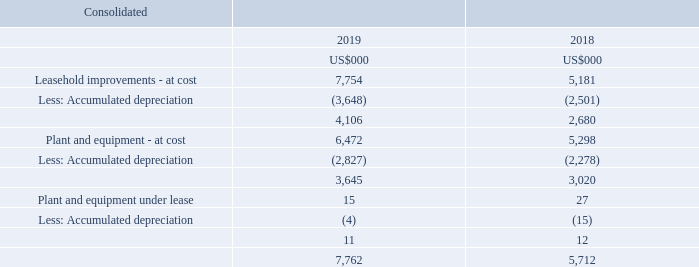Note 9. Non-current assets - property, plant and equipment
Property, plant and equipment secured under finance leases
Refer to note 24 for further information on property, plant and equipment secured under finance leases.
Accounting policy for property, plant and equipment
Plant and equipment are stated at cost less accumulated depreciation and any accumulated impairment losses. Cost includes expenditure that is directly attributable to the acquisition of the items. Subsequent costs are included in the assets carrying amount or recognised as a separate asset, as appropriate, only when it is probable that future economic benefits associated with the item will flow to the group and the cost of the item can be measured reliably.
Plant and equipment are depreciated and leasehold improvements are amortised over their estimated useful lives using the straightline method. Assets held under finance lease are depreciated over their expected useful lives as owned assets or, where shorter, the term of the relevant lease.
What is the total consolidated amount in 2019?
Answer scale should be: thousand. 7,762. When are subsequent costs included? When it is probable that future economic benefits associated with the item will flow to the group and the cost of the item can be measured reliably. What are the years included in the table? 2019, 2018. Which year had a higher total consolidated Non-current assets value?  7,762 > 5,712 
Answer: 2019. What is the percentage change in the plant and equipment at cost less accumulated depreciation from 2018 to 2019?
Answer scale should be: percent. (3,645-3,020)/3,020
Answer: 20.7. What is the percentage change in the leasehold improvements before depreciation from 2018 from 2019?
Answer scale should be: percent. (7,754-5,181)/5,181
Answer: 49.66. 